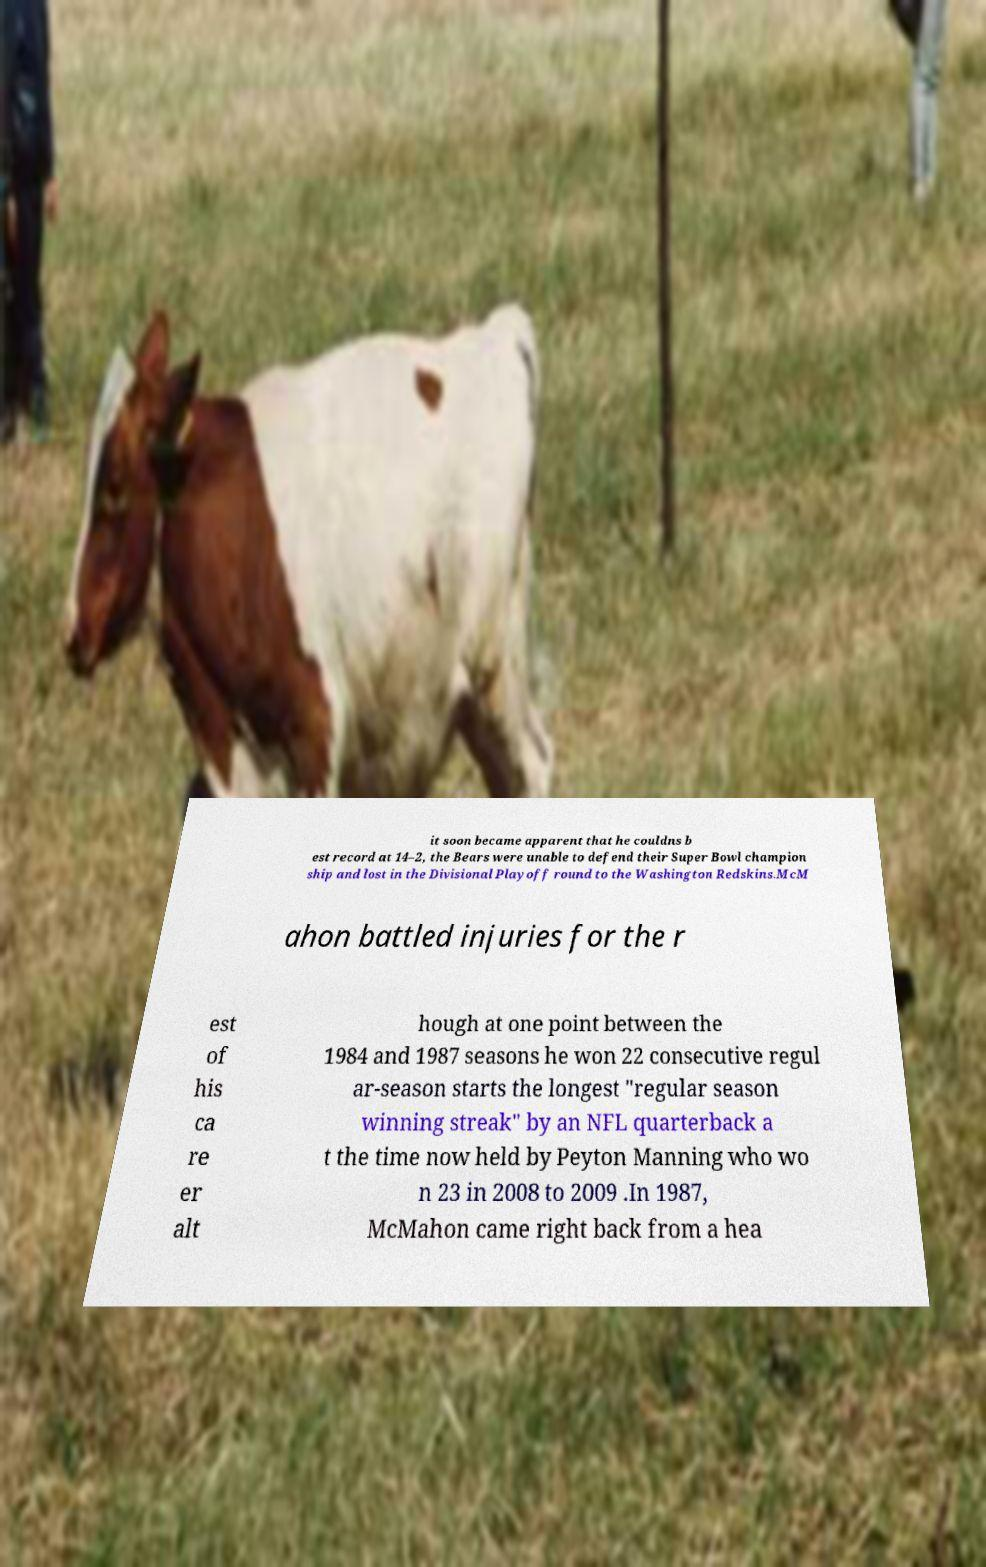Can you read and provide the text displayed in the image?This photo seems to have some interesting text. Can you extract and type it out for me? it soon became apparent that he couldns b est record at 14–2, the Bears were unable to defend their Super Bowl champion ship and lost in the Divisional Playoff round to the Washington Redskins.McM ahon battled injuries for the r est of his ca re er alt hough at one point between the 1984 and 1987 seasons he won 22 consecutive regul ar-season starts the longest "regular season winning streak" by an NFL quarterback a t the time now held by Peyton Manning who wo n 23 in 2008 to 2009 .In 1987, McMahon came right back from a hea 